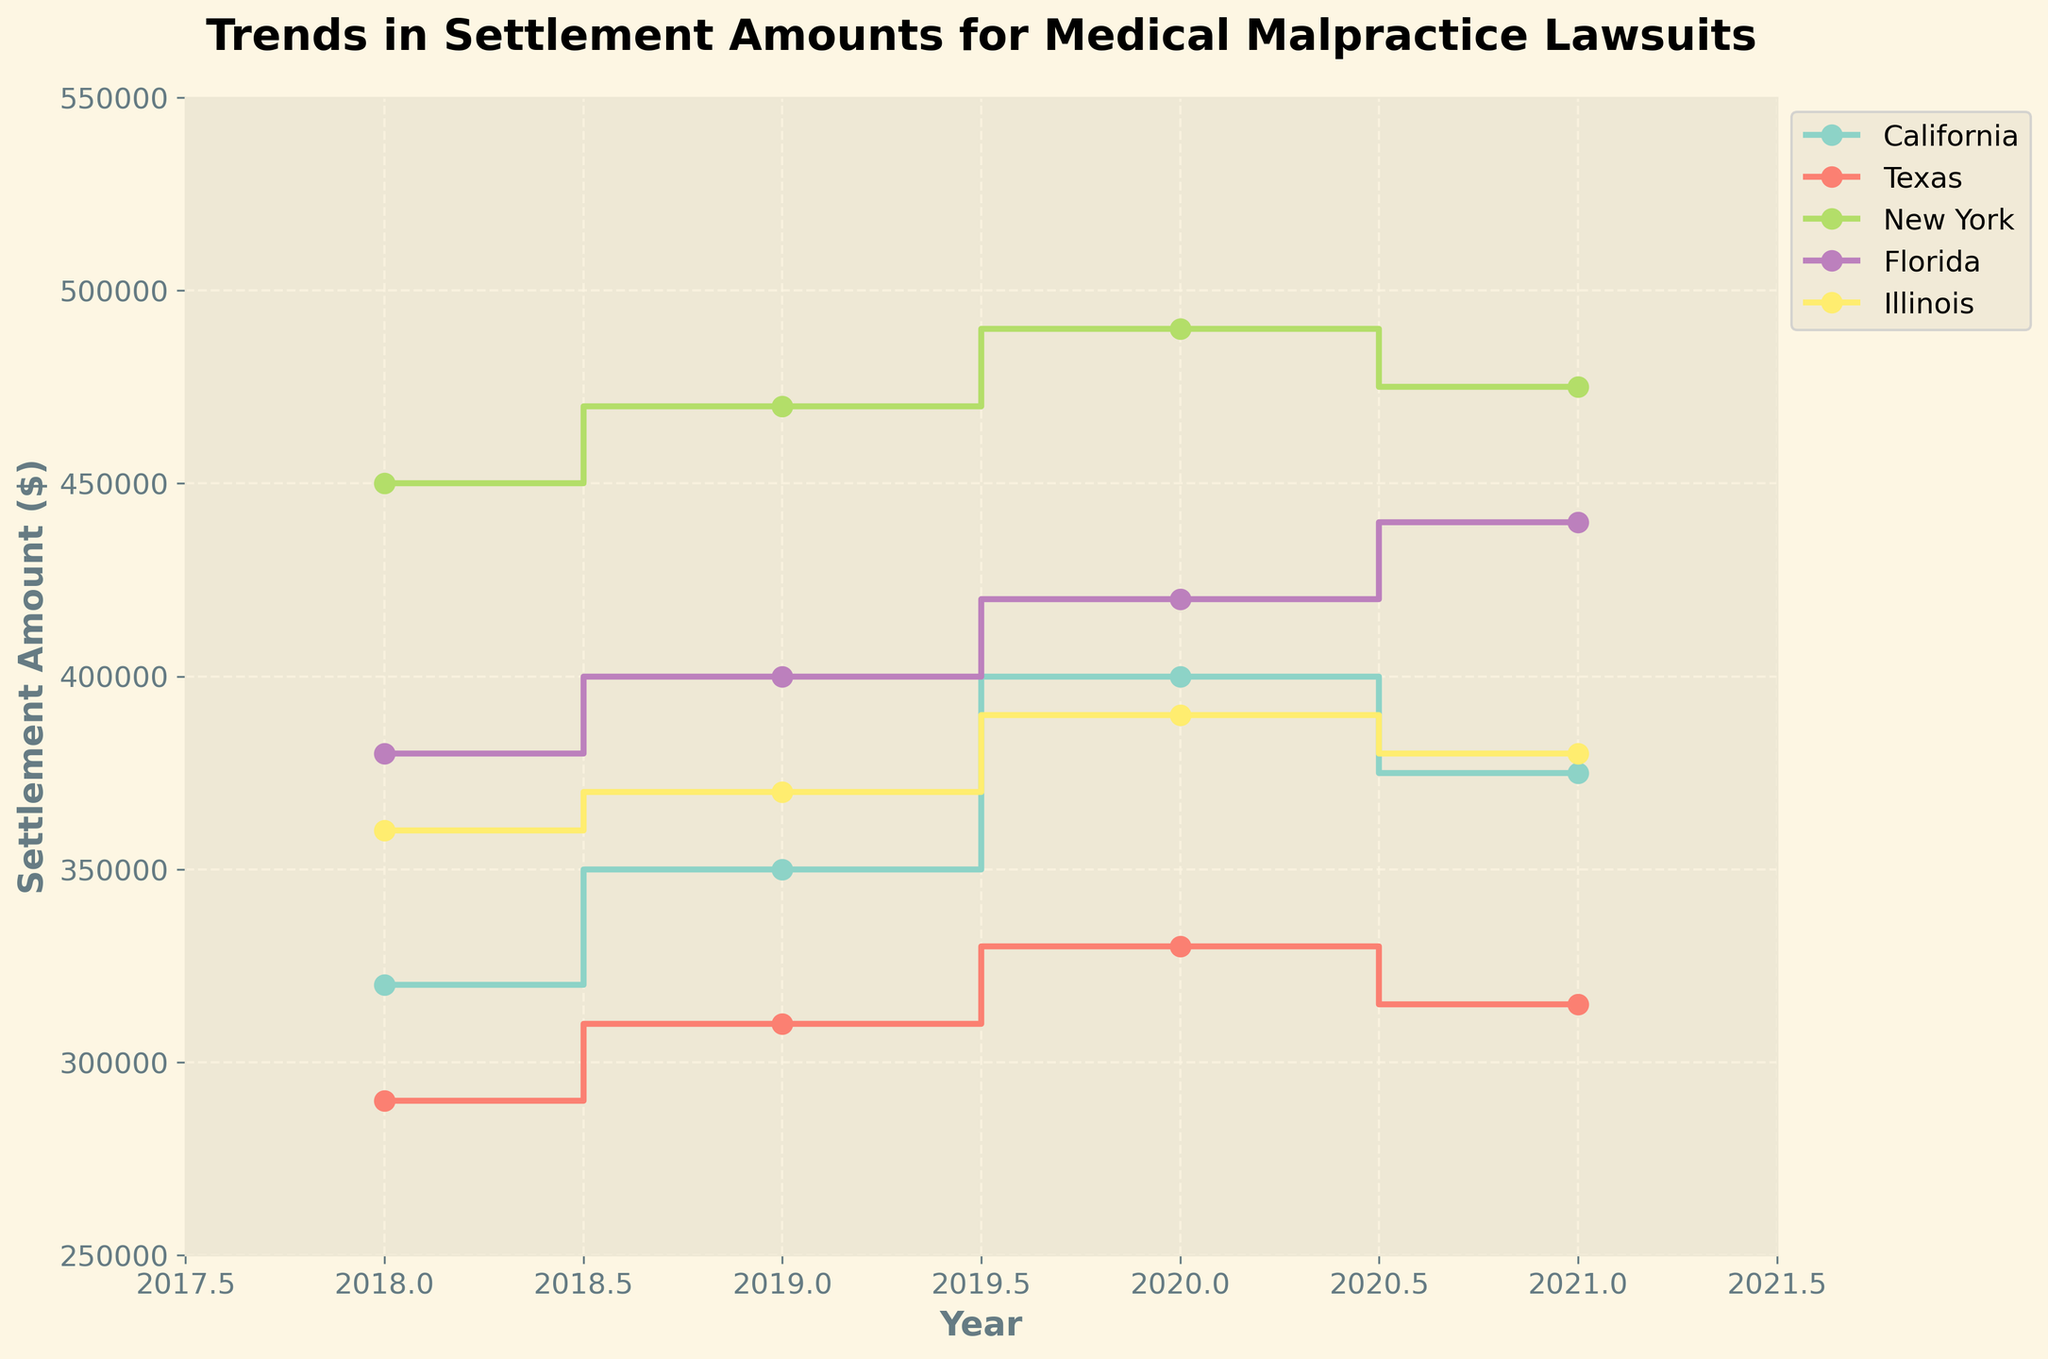What is the title of the figure? The title of the figure is usually located at the top and provides a clear summary of what the figure represents.
Answer: Trends in Settlement Amounts for Medical Malpractice Lawsuits Which state had the highest settlement amount in 2020? To determine which state had the highest settlement amount in 2020, we look at the 2020 data points and compare the values across all states.
Answer: New York How did California's settlement amounts change from 2018 to 2021? By tracking the step plot for California from 2018 to 2021, we can see the changes in settlement amounts. We observe the directional changes between each year's data point.
Answer: Increase, Increase, Decrease What is the overall trend in settlement amounts for Texas from 2018 to 2021? Observing the plot for Texas, we look at the settlement amounts at each year and the direction in which they change to understand the trend.
Answer: Increasing, then Decreasing Which state had the most consistent settlement amounts from 2018 to 2021? To find the most consistent state, we compare the fluctuation in settlement amounts for each state over the years. The state with the least variation is considered the most consistent.
Answer: Texas What is the difference in settlement amount between New York and Illinois in 2019? Observe the data points for New York and Illinois in 2019, then calculate the absolute difference between the two settlement amounts.
Answer: $100,000 How many unique years of data are represented in the figure? Count the number of distinct years reported on the x-axis, which reflects the time period covered by the figure.
Answer: 4 During which year did Florida see the highest increase in settlement amounts? By comparing the step differences between consecutive years for Florida, the year with the largest positive change in settlement amounts can be identified.
Answer: 2021 What's the average settlement amount for California from 2018 to 2021? Add the settlement amounts for California from 2018 to 2021, and divide by the number of years (4) to calculate the average.
Answer: $361,250 Which year showed the highest aggregate settlement amount across all states? First, find the settlement amount for each state in each year. Sum the amounts for all states per year, then identify the year with the highest sum.
Answer: 2020 